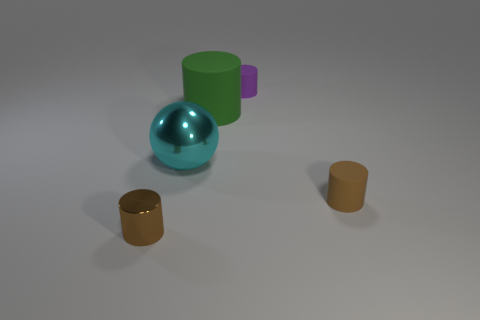The tiny metal thing that is the same shape as the large rubber thing is what color?
Give a very brief answer. Brown. There is a small thing that is behind the brown cylinder to the right of the large object that is behind the big cyan metal thing; what shape is it?
Make the answer very short. Cylinder. Do the small purple matte object and the green object have the same shape?
Keep it short and to the point. Yes. There is a tiny matte thing on the left side of the small rubber object that is in front of the green thing; what is its shape?
Give a very brief answer. Cylinder. Are any small cyan matte cylinders visible?
Ensure brevity in your answer.  No. What number of green rubber cylinders are in front of the tiny brown thing that is in front of the tiny brown cylinder that is behind the shiny cylinder?
Your answer should be compact. 0. Do the big matte thing and the tiny brown object to the left of the big metal ball have the same shape?
Provide a succinct answer. Yes. Is the number of small objects greater than the number of tiny metallic spheres?
Make the answer very short. Yes. Is there any other thing that is the same size as the cyan object?
Make the answer very short. Yes. Does the metallic object to the left of the big metal sphere have the same shape as the big cyan shiny object?
Provide a short and direct response. No. 